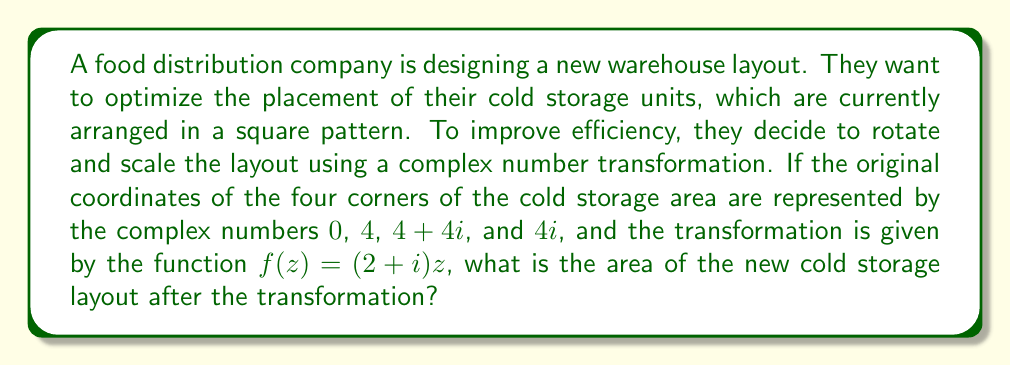What is the answer to this math problem? To solve this problem, we'll follow these steps:

1) First, let's understand what the transformation $f(z) = (2+i)z$ does:
   - It scales the figure by a factor of $\sqrt{2^2 + 1^2} = \sqrt{5}$
   - It rotates the figure by $\arctan(\frac{1}{2})$ radians counterclockwise

2) The original coordinates in the complex plane are:
   $z_1 = 0$
   $z_2 = 4$
   $z_3 = 4+4i$
   $z_4 = 4i$

3) After the transformation, the new coordinates will be:
   $w_1 = f(z_1) = (2+i)(0) = 0$
   $w_2 = f(z_2) = (2+i)(4) = 8+4i$
   $w_3 = f(z_3) = (2+i)(4+4i) = 8+4i+8i-4 = 4+12i$
   $w_4 = f(z_4) = (2+i)(4i) = 8i-4 = -4+8i$

4) The original shape was a square with side length 4, so its area was 16 square units.

5) The transformation scales all distances by a factor of $\sqrt{5}$. Since area scales with the square of linear dimensions, the new area will be $16 * 5 = 80$ square units.

6) We can verify this by calculating the area of the new parallelogram:
   - One side is $w_2 - w_1 = 8+4i$
   - The adjacent side is $w_4 - w_1 = -4+8i$
   - The area of a parallelogram with complex sides $a+bi$ and $c+di$ is $|ad-bc|$
   - Area $= |(8)(8) - (4)(-4)| = |64 + 16| = 80$ square units

Therefore, the area of the new cold storage layout is 80 square units.
Answer: 80 square units 